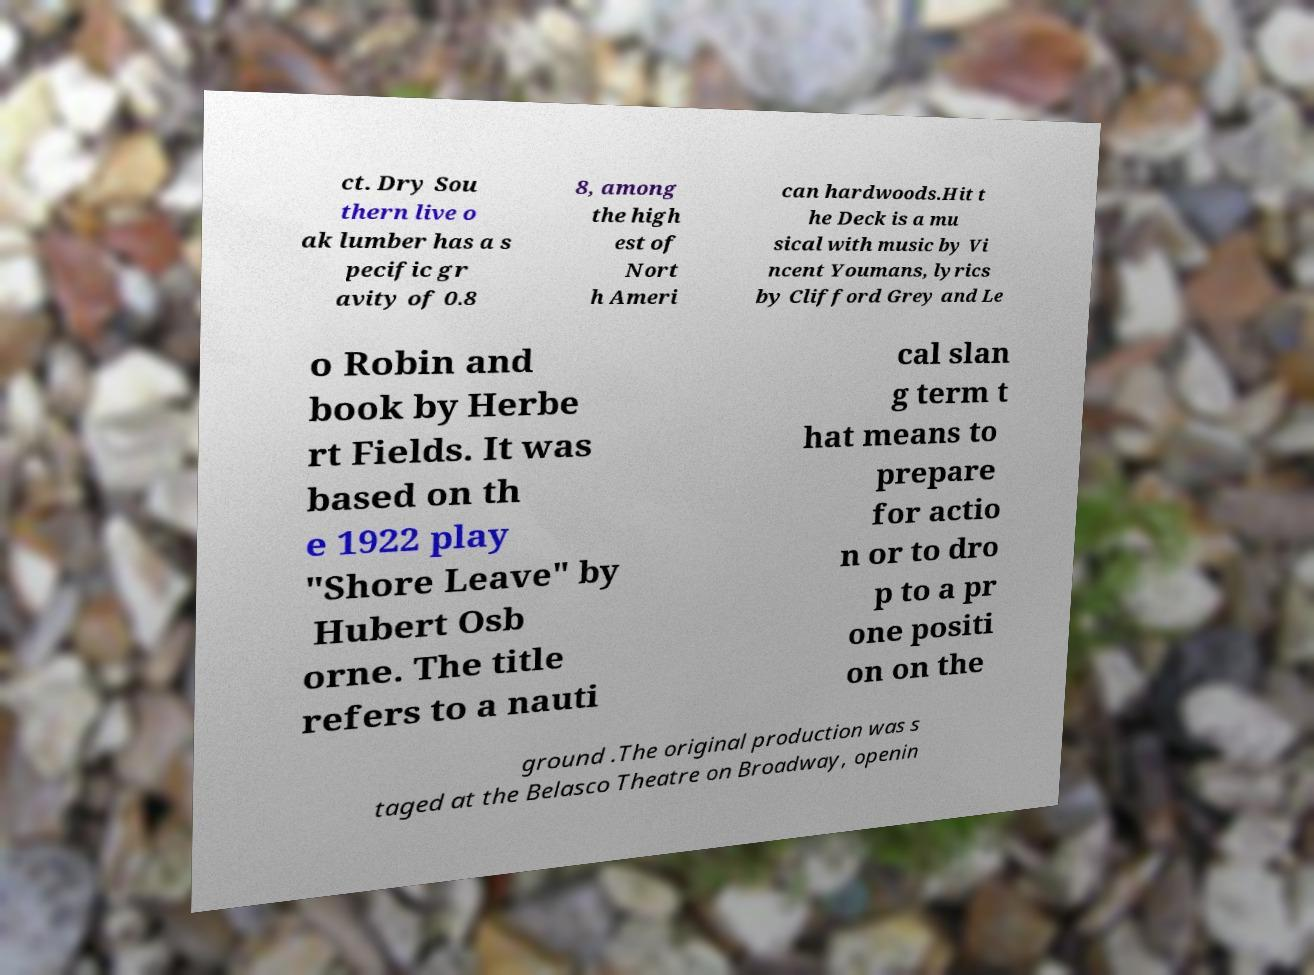There's text embedded in this image that I need extracted. Can you transcribe it verbatim? ct. Dry Sou thern live o ak lumber has a s pecific gr avity of 0.8 8, among the high est of Nort h Ameri can hardwoods.Hit t he Deck is a mu sical with music by Vi ncent Youmans, lyrics by Clifford Grey and Le o Robin and book by Herbe rt Fields. It was based on th e 1922 play "Shore Leave" by Hubert Osb orne. The title refers to a nauti cal slan g term t hat means to prepare for actio n or to dro p to a pr one positi on on the ground .The original production was s taged at the Belasco Theatre on Broadway, openin 